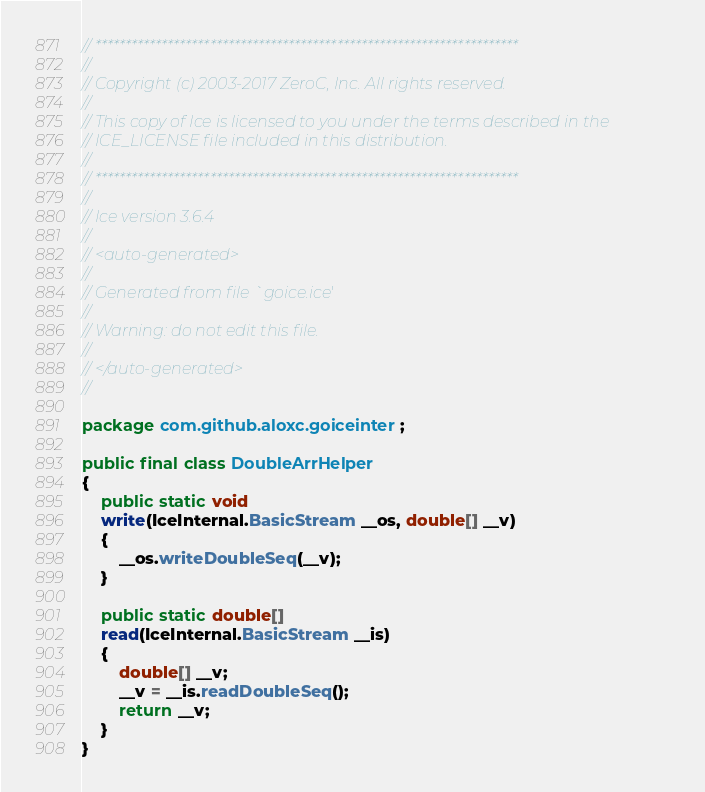<code> <loc_0><loc_0><loc_500><loc_500><_Java_>// **********************************************************************
//
// Copyright (c) 2003-2017 ZeroC, Inc. All rights reserved.
//
// This copy of Ice is licensed to you under the terms described in the
// ICE_LICENSE file included in this distribution.
//
// **********************************************************************
//
// Ice version 3.6.4
//
// <auto-generated>
//
// Generated from file `goice.ice'
//
// Warning: do not edit this file.
//
// </auto-generated>
//

package com.github.aloxc.goiceinter;

public final class DoubleArrHelper
{
    public static void
    write(IceInternal.BasicStream __os, double[] __v)
    {
        __os.writeDoubleSeq(__v);
    }

    public static double[]
    read(IceInternal.BasicStream __is)
    {
        double[] __v;
        __v = __is.readDoubleSeq();
        return __v;
    }
}
</code> 